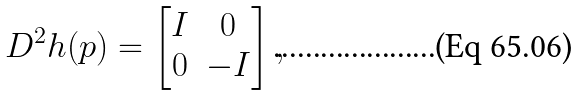Convert formula to latex. <formula><loc_0><loc_0><loc_500><loc_500>D ^ { 2 } h ( p ) = \begin{bmatrix} I & 0 \\ 0 & - I \\ \end{bmatrix} ,</formula> 